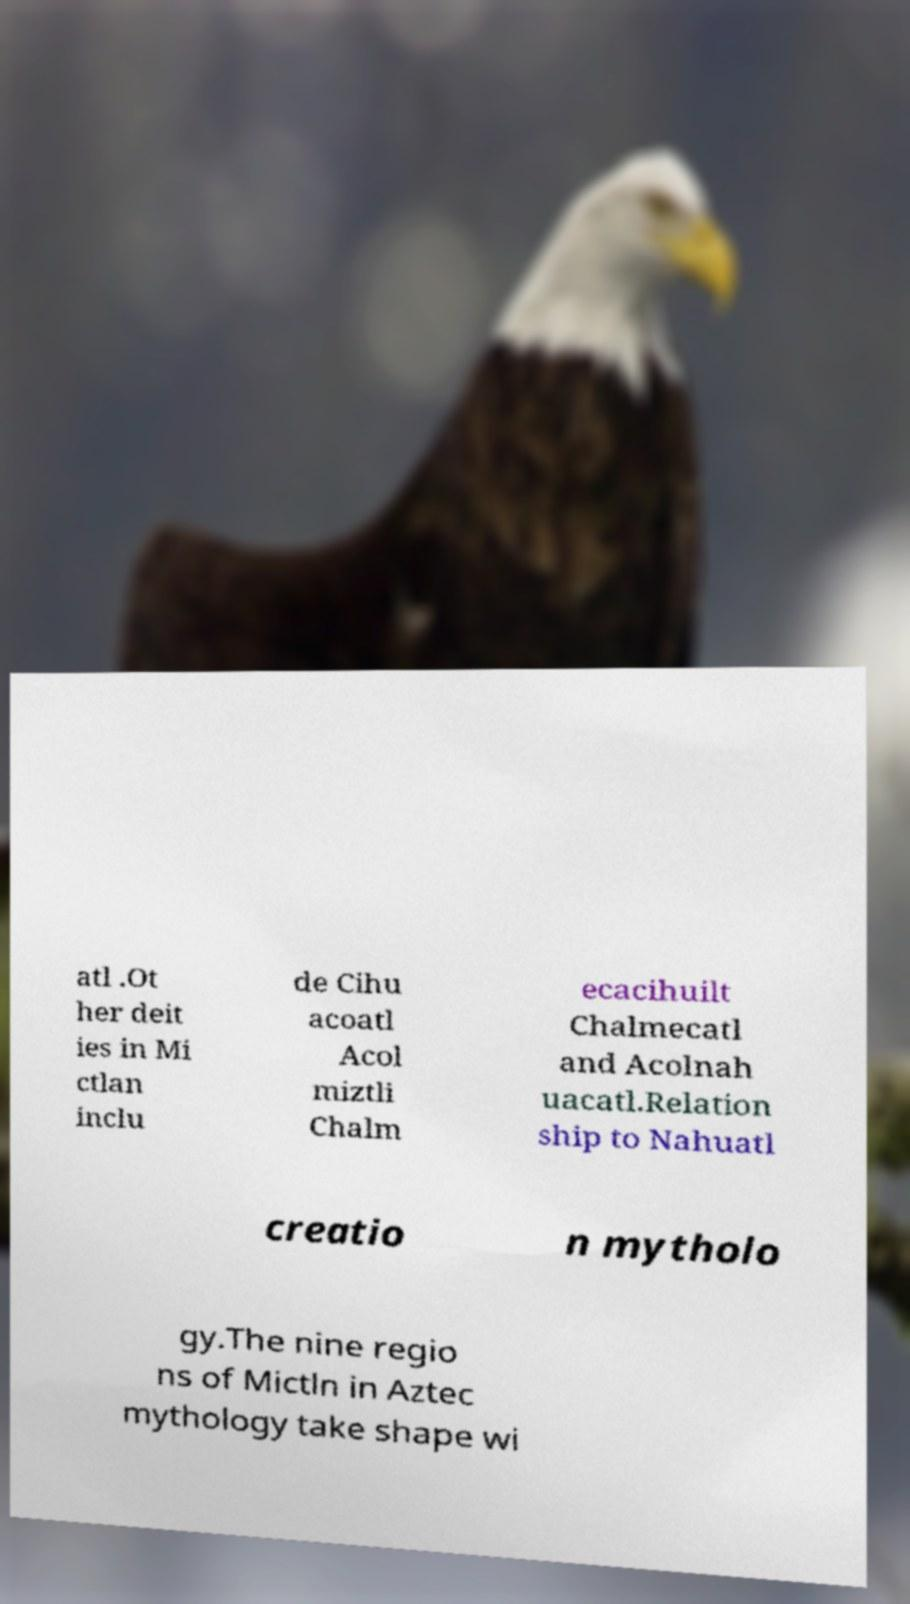Could you extract and type out the text from this image? atl .Ot her deit ies in Mi ctlan inclu de Cihu acoatl Acol miztli Chalm ecacihuilt Chalmecatl and Acolnah uacatl.Relation ship to Nahuatl creatio n mytholo gy.The nine regio ns of Mictln in Aztec mythology take shape wi 